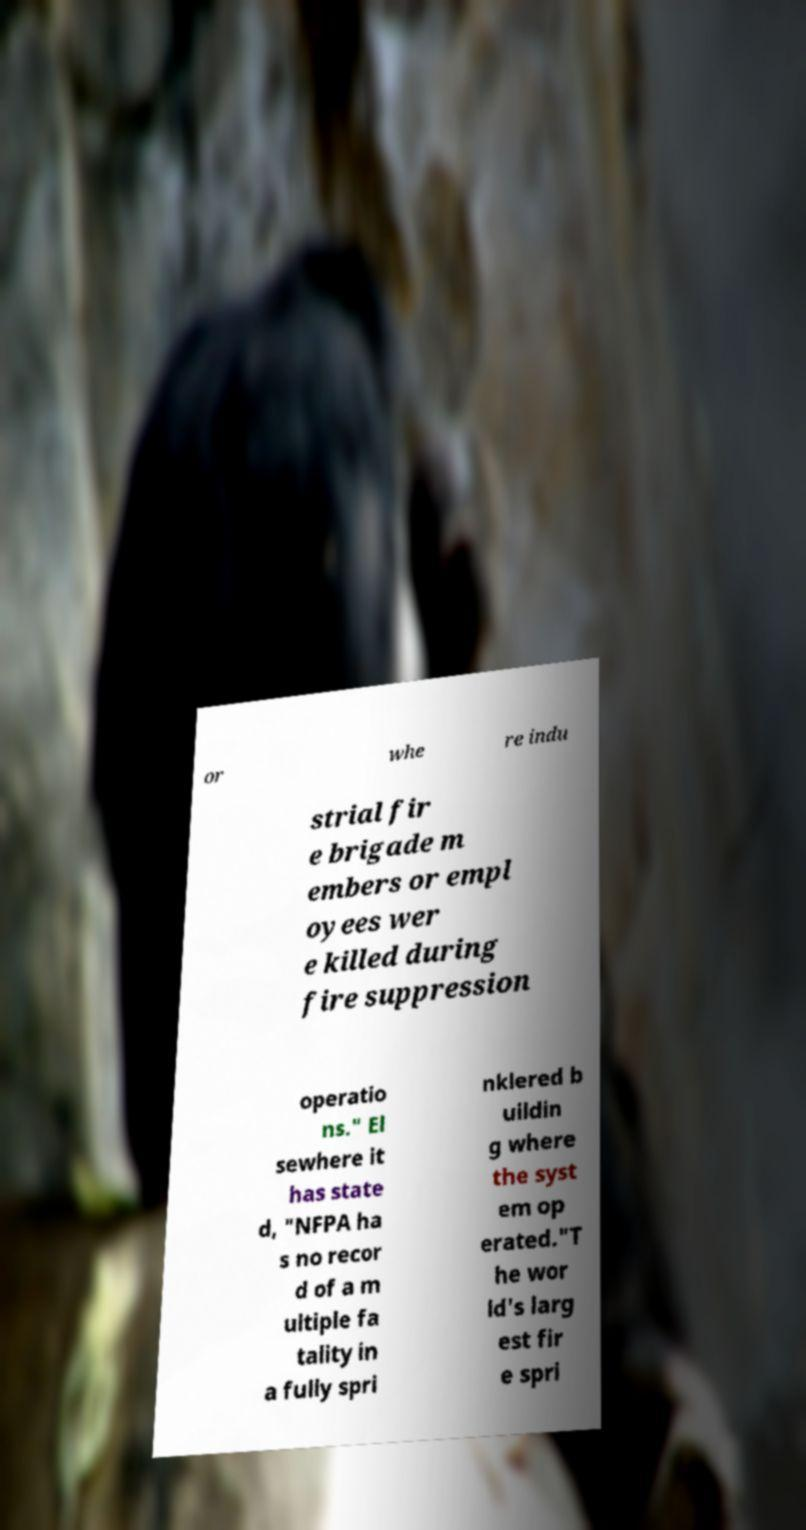What messages or text are displayed in this image? I need them in a readable, typed format. or whe re indu strial fir e brigade m embers or empl oyees wer e killed during fire suppression operatio ns." El sewhere it has state d, "NFPA ha s no recor d of a m ultiple fa tality in a fully spri nklered b uildin g where the syst em op erated."T he wor ld's larg est fir e spri 